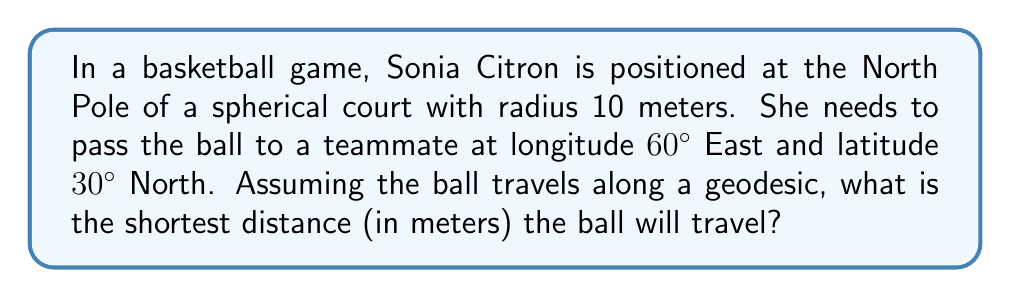Solve this math problem. Let's approach this step-by-step:

1) On a sphere, geodesics are great circles. The shortest path between two points on a sphere is along the arc of the great circle passing through those points.

2) To find the length of this arc, we need to calculate the central angle between the two points and then use the arc length formula.

3) We can use the spherical law of cosines to find the central angle $\theta$:

   $$\cos(\theta) = \sin(\phi_1)\sin(\phi_2) + \cos(\phi_1)\cos(\phi_2)\cos(\Delta\lambda)$$

   Where:
   $\phi_1$ is the latitude of point 1 (North Pole = 90°)
   $\phi_2$ is the latitude of point 2 (30° North)
   $\Delta\lambda$ is the difference in longitude (60°)

4) Plugging in the values:

   $$\cos(\theta) = \sin(90°)\sin(30°) + \cos(90°)\cos(30°)\cos(60°)$$

5) Simplifying:

   $$\cos(\theta) = (1)(0.5) + (0)(0.866)(0.5) = 0.5$$

6) Taking the inverse cosine:

   $$\theta = \arccos(0.5) \approx 1.0472 \text{ radians}$$

7) Now we can use the arc length formula:

   $$s = r\theta$$

   Where $r$ is the radius of the sphere (10 meters)

8) Calculating the arc length:

   $$s = 10 * 1.0472 \approx 10.472 \text{ meters}$$
Answer: 10.472 meters 